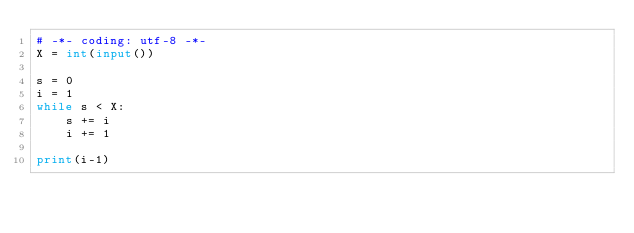Convert code to text. <code><loc_0><loc_0><loc_500><loc_500><_Python_># -*- coding: utf-8 -*-
X = int(input())

s = 0
i = 1
while s < X:
    s += i
    i += 1

print(i-1)</code> 